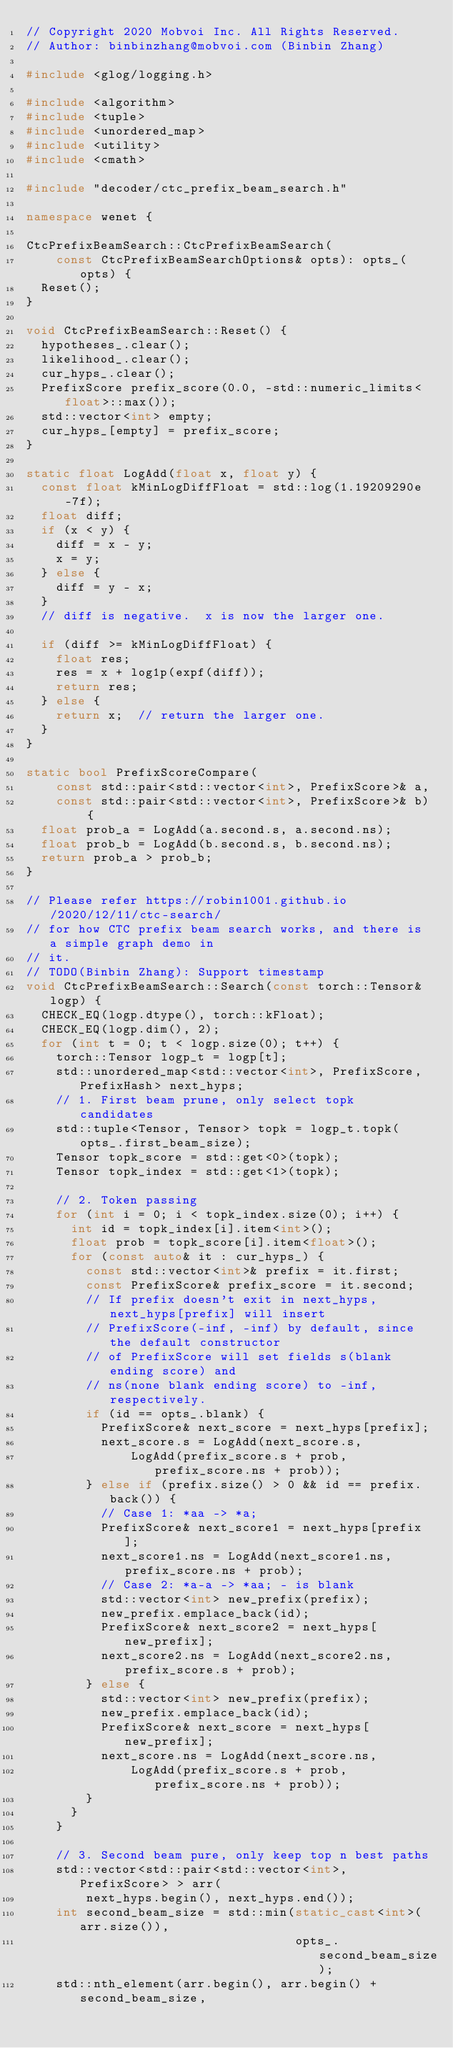<code> <loc_0><loc_0><loc_500><loc_500><_C++_>// Copyright 2020 Mobvoi Inc. All Rights Reserved.
// Author: binbinzhang@mobvoi.com (Binbin Zhang)

#include <glog/logging.h>

#include <algorithm>
#include <tuple>
#include <unordered_map>
#include <utility>
#include <cmath>

#include "decoder/ctc_prefix_beam_search.h"

namespace wenet {

CtcPrefixBeamSearch::CtcPrefixBeamSearch(
    const CtcPrefixBeamSearchOptions& opts): opts_(opts) {
  Reset();
}

void CtcPrefixBeamSearch::Reset() {
  hypotheses_.clear();
  likelihood_.clear();
  cur_hyps_.clear();
  PrefixScore prefix_score(0.0, -std::numeric_limits<float>::max());
  std::vector<int> empty;
  cur_hyps_[empty] = prefix_score;
}

static float LogAdd(float x, float y) {
  const float kMinLogDiffFloat = std::log(1.19209290e-7f);
  float diff;
  if (x < y) {
    diff = x - y;
    x = y;
  } else {
    diff = y - x;
  }
  // diff is negative.  x is now the larger one.

  if (diff >= kMinLogDiffFloat) {
    float res;
    res = x + log1p(expf(diff));
    return res;
  } else {
    return x;  // return the larger one.
  }
}

static bool PrefixScoreCompare(
    const std::pair<std::vector<int>, PrefixScore>& a,
    const std::pair<std::vector<int>, PrefixScore>& b) {
  float prob_a = LogAdd(a.second.s, a.second.ns);
  float prob_b = LogAdd(b.second.s, b.second.ns);
  return prob_a > prob_b;
}

// Please refer https://robin1001.github.io/2020/12/11/ctc-search/
// for how CTC prefix beam search works, and there is a simple graph demo in
// it.
// TODO(Binbin Zhang): Support timestamp
void CtcPrefixBeamSearch::Search(const torch::Tensor& logp) {
  CHECK_EQ(logp.dtype(), torch::kFloat);
  CHECK_EQ(logp.dim(), 2);
  for (int t = 0; t < logp.size(0); t++) {
    torch::Tensor logp_t = logp[t];
    std::unordered_map<std::vector<int>, PrefixScore, PrefixHash> next_hyps;
    // 1. First beam prune, only select topk candidates
    std::tuple<Tensor, Tensor> topk = logp_t.topk(opts_.first_beam_size);
    Tensor topk_score = std::get<0>(topk);
    Tensor topk_index = std::get<1>(topk);

    // 2. Token passing
    for (int i = 0; i < topk_index.size(0); i++) {
      int id = topk_index[i].item<int>();
      float prob = topk_score[i].item<float>();
      for (const auto& it : cur_hyps_) {
        const std::vector<int>& prefix = it.first;
        const PrefixScore& prefix_score = it.second;
        // If prefix doesn't exit in next_hyps, next_hyps[prefix] will insert
        // PrefixScore(-inf, -inf) by default, since the default constructor
        // of PrefixScore will set fields s(blank ending score) and
        // ns(none blank ending score) to -inf, respectively.
        if (id == opts_.blank) {
          PrefixScore& next_score = next_hyps[prefix];
          next_score.s = LogAdd(next_score.s,
              LogAdd(prefix_score.s + prob, prefix_score.ns + prob));
        } else if (prefix.size() > 0 && id == prefix.back()) {
          // Case 1: *aa -> *a;
          PrefixScore& next_score1 = next_hyps[prefix];
          next_score1.ns = LogAdd(next_score1.ns, prefix_score.ns + prob);
          // Case 2: *a-a -> *aa; - is blank
          std::vector<int> new_prefix(prefix);
          new_prefix.emplace_back(id);
          PrefixScore& next_score2 = next_hyps[new_prefix];
          next_score2.ns = LogAdd(next_score2.ns, prefix_score.s + prob);
        } else {
          std::vector<int> new_prefix(prefix);
          new_prefix.emplace_back(id);
          PrefixScore& next_score = next_hyps[new_prefix];
          next_score.ns = LogAdd(next_score.ns,
              LogAdd(prefix_score.s + prob, prefix_score.ns + prob));
        }
      }
    }

    // 3. Second beam pure, only keep top n best paths
    std::vector<std::pair<std::vector<int>, PrefixScore> > arr(
        next_hyps.begin(), next_hyps.end());
    int second_beam_size = std::min(static_cast<int>(arr.size()),
                                    opts_.second_beam_size);
    std::nth_element(arr.begin(), arr.begin() + second_beam_size,</code> 